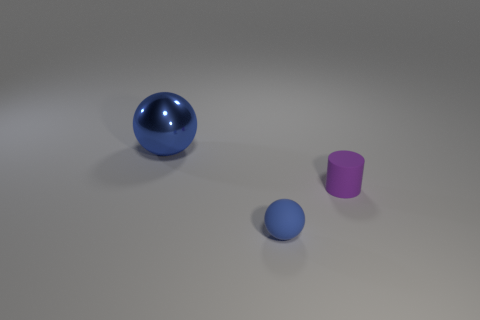There is a purple object that is the same size as the blue matte thing; what is its material?
Offer a very short reply. Rubber. How many other objects are there of the same material as the purple object?
Provide a short and direct response. 1. Are there fewer purple cylinders behind the large blue shiny ball than tiny matte spheres?
Your answer should be very brief. Yes. Is the small blue rubber thing the same shape as the blue metallic object?
Provide a succinct answer. Yes. There is a sphere that is behind the blue thing that is right of the blue ball left of the small blue matte object; what is its size?
Give a very brief answer. Large. There is another tiny blue thing that is the same shape as the shiny thing; what is its material?
Offer a very short reply. Rubber. Is there anything else that has the same size as the purple matte cylinder?
Offer a terse response. Yes. There is a matte thing right of the blue sphere that is in front of the big sphere; what is its size?
Make the answer very short. Small. What color is the metal thing?
Your answer should be very brief. Blue. How many blue rubber balls are in front of the purple matte cylinder that is on the right side of the blue matte ball?
Make the answer very short. 1. 